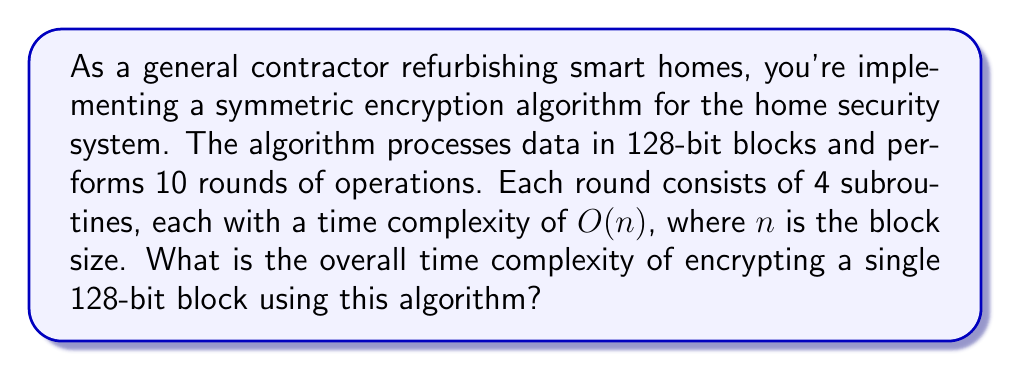Give your solution to this math problem. Let's break down the problem step-by-step:

1) The algorithm processes data in 128-bit blocks, so $n = 128$.

2) There are 10 rounds of operations.

3) Each round consists of 4 subroutines.

4) Each subroutine has a time complexity of $O(n)$.

5) For a single round, the time complexity is:
   $$O(n) + O(n) + O(n) + O(n) = 4 \cdot O(n) = O(n)$$

6) Since there are 10 rounds, the total time complexity is:
   $$10 \cdot O(n) = O(n)$$

7) The number of rounds and subroutines are constants and don't depend on the input size, so they don't affect the big-O notation.

8) Therefore, the overall time complexity for encrypting a single 128-bit block remains $O(n)$, where $n$ is the block size.
Answer: $O(n)$ 